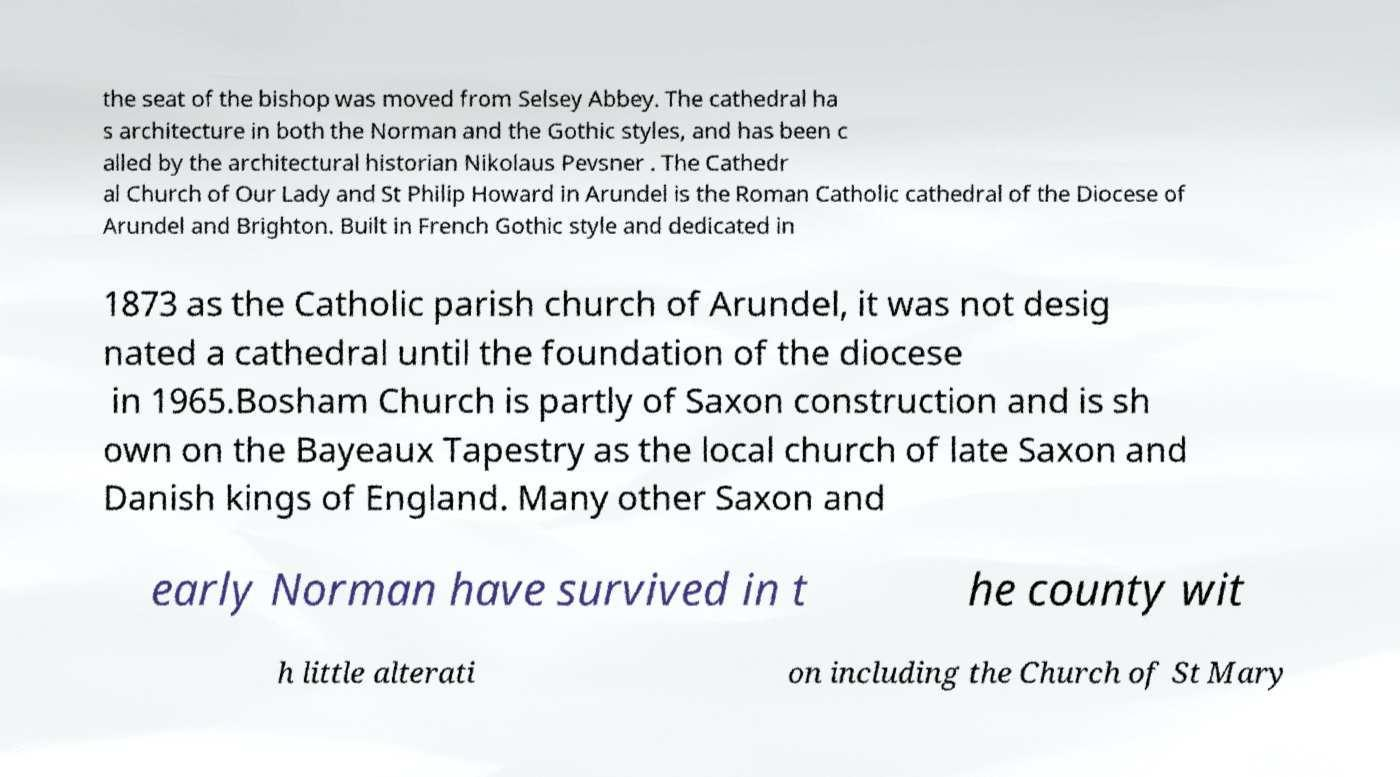Please identify and transcribe the text found in this image. the seat of the bishop was moved from Selsey Abbey. The cathedral ha s architecture in both the Norman and the Gothic styles, and has been c alled by the architectural historian Nikolaus Pevsner . The Cathedr al Church of Our Lady and St Philip Howard in Arundel is the Roman Catholic cathedral of the Diocese of Arundel and Brighton. Built in French Gothic style and dedicated in 1873 as the Catholic parish church of Arundel, it was not desig nated a cathedral until the foundation of the diocese in 1965.Bosham Church is partly of Saxon construction and is sh own on the Bayeaux Tapestry as the local church of late Saxon and Danish kings of England. Many other Saxon and early Norman have survived in t he county wit h little alterati on including the Church of St Mary 